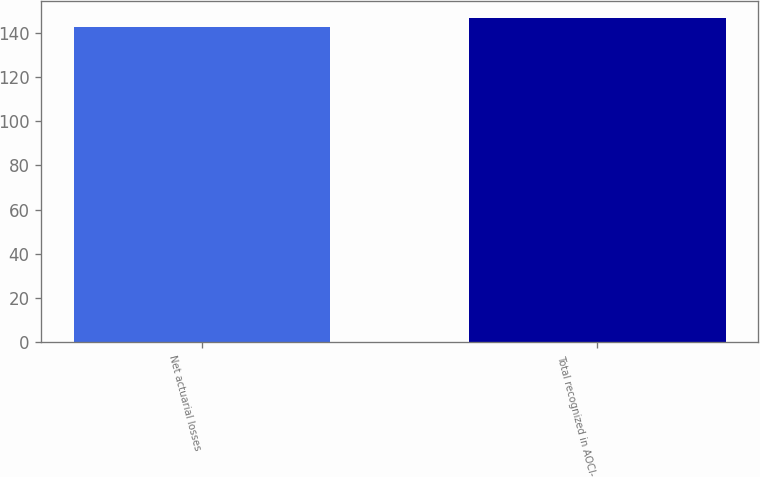<chart> <loc_0><loc_0><loc_500><loc_500><bar_chart><fcel>Net actuarial losses<fcel>Total recognized in AOCI-<nl><fcel>142.7<fcel>146.7<nl></chart> 